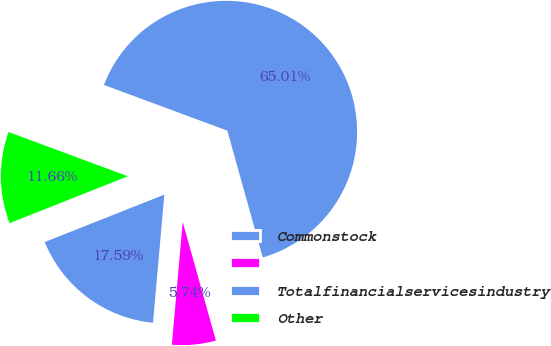Convert chart to OTSL. <chart><loc_0><loc_0><loc_500><loc_500><pie_chart><fcel>Commonstock<fcel>Unnamed: 1<fcel>Totalfinancialservicesindustry<fcel>Other<nl><fcel>17.59%<fcel>5.74%<fcel>65.01%<fcel>11.66%<nl></chart> 